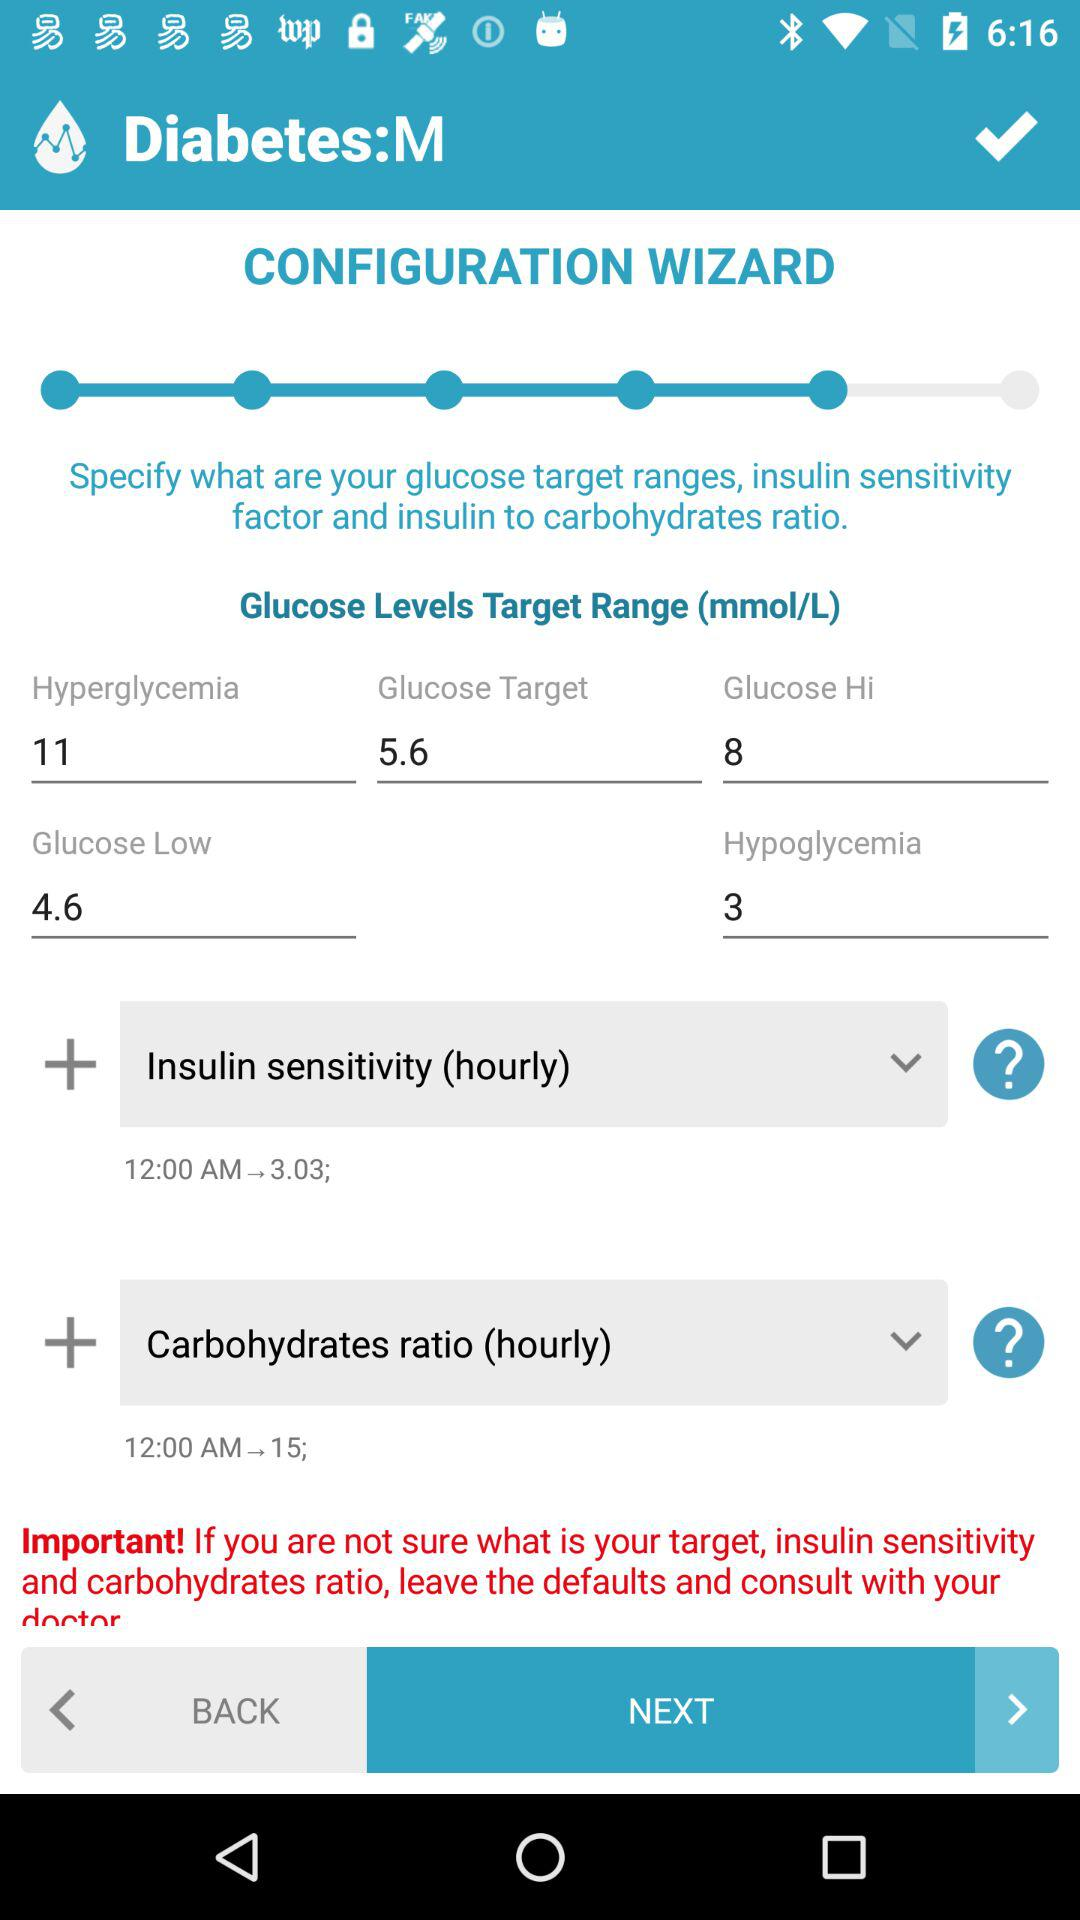What is the time mentioned under "Insulin sensitivity (hourly)"? The time mentioned under "Insulin sensitivity (hourly)" is 12 AM. 